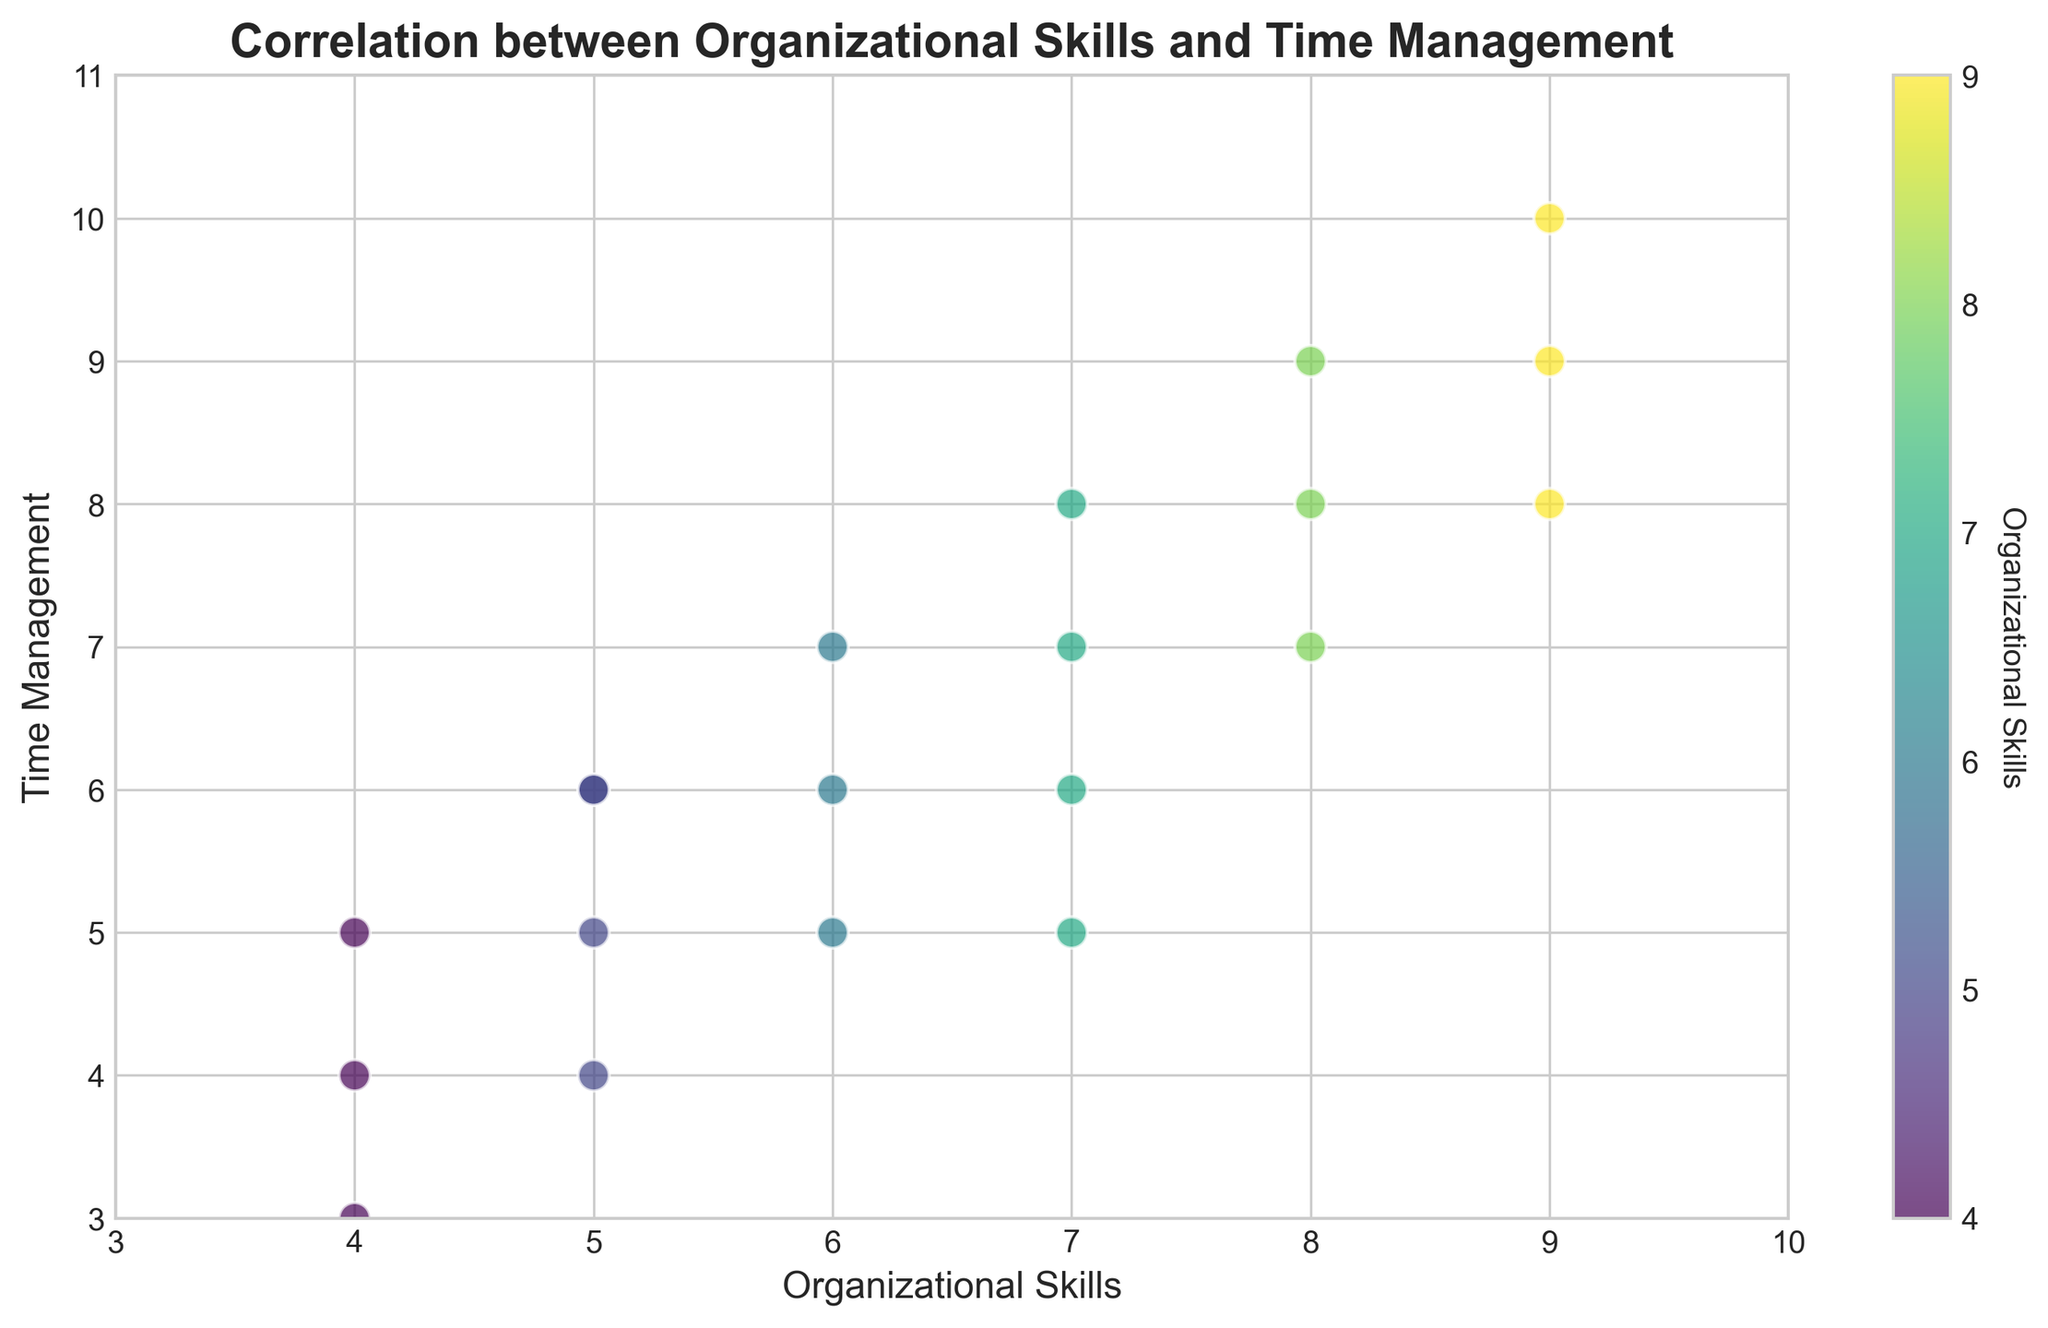How does the scatter plot visually differentiate between higher and lower levels of organizational skills using colors? The scatter plot uses a color gradient (likely from a colormap like viridis) to represent organizational skills. Dots with higher organizational skills are shown in brighter, more yellowish colors, while lower organizational skills are depicted in darker, purplish colors. This helps in visually differentiating the levels of organizational skills directly through the color intensity.
Answer: By color intensity, higher levels are brighter yellow, and lower levels are darker purple Which data point has the highest time management score and what is its organizational skills value? The highest time management score is indicated by the y-axis value of 10. Referring to the corresponding x-axis value, this data point has an organizational skills value of 9.
Answer: Organizational Skills: 9 Are there any data points where organizational skills and time management scores are equal? Checking the plot, we see that several points lie on the 45-degree line where the x and y values are equal, indicating equal scores for organizational skills and time management. The points are (4, 4), (5, 5), (6, 6), (7, 7), (8, 8), and (9, 9).
Answer: Yes, at (4, 4), (5, 5), (6, 6), (7, 7), (8, 8), and (9, 9) How many data points have an organizational skills score greater than 7? By examining the scatter plot and focusing on points right of the x-axis value of 7, we find data points at (8, 7), (9, 8), (8, 9), (9, 9), (8, 8), and (9, 10). This totals to six data points.
Answer: Six What is the median value of time management scores for all the data points? To find the median, first sort the time management scores: 3, 4, 4, 5, 5, 5, 5, 6, 6, 6, 6, 7, 7, 7, 7, 8, 8, 9, 9, 10. With 20 points, the median is the average of the 10th and 11th values: (6 + 6) / 2 = 6.
Answer: 6 Which color represents the lowest organizational skills, and how many data points are shown in this color? The lowest organizational skills are represented by the darkest color (purplish). By counting points in this color, we find four data points: (4, 4), (4, 3), (4, 5), (4, 5).
Answer: Darkest color, Four Is there a positive correlation between organizational skills and time management based on the scatter plot? A positive correlation means that as one variable increases, so does the other. The scatter plot shows that most points move in an upward trend from the bottom-left to top-right, indicating a positive correlation.
Answer: Yes Which pair of organizational skills and time management scores are the most aligned with the trendline? Points directly on the 45-degree line from the origin are perfectly aligned with the trendline indicating y = x. These points are (4, 4), (5, 5), (6, 6), (7, 7), (8, 8), and (9, 9).
Answer: (4, 4), (5, 5), (6, 6), (7, 7), (8, 8), and (9, 9) What is the range of the time management scores depicted in the scatter plot? The range is determined by subtracting the smallest value from the largest value. The smallest time management score is 3, and the highest is 10. So, the range is 10 - 3 = 7.
Answer: 7 